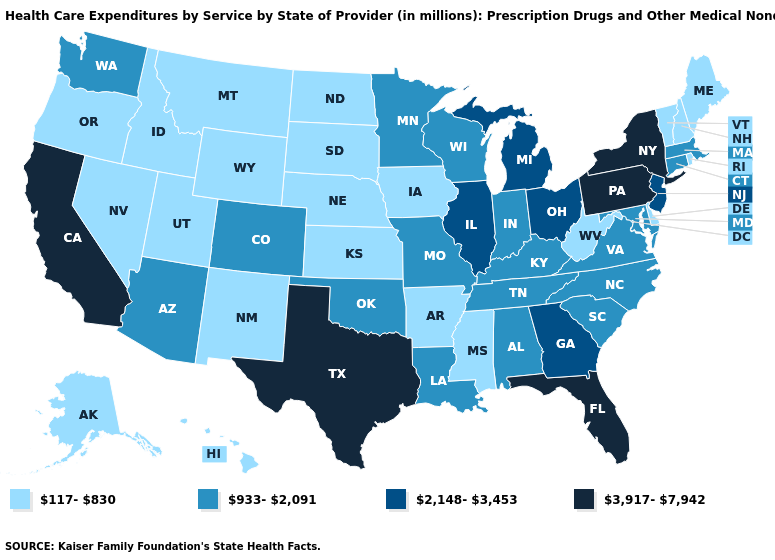Among the states that border Louisiana , does Mississippi have the lowest value?
Be succinct. Yes. What is the value of Idaho?
Keep it brief. 117-830. What is the value of Georgia?
Answer briefly. 2,148-3,453. Name the states that have a value in the range 117-830?
Give a very brief answer. Alaska, Arkansas, Delaware, Hawaii, Idaho, Iowa, Kansas, Maine, Mississippi, Montana, Nebraska, Nevada, New Hampshire, New Mexico, North Dakota, Oregon, Rhode Island, South Dakota, Utah, Vermont, West Virginia, Wyoming. What is the value of Colorado?
Be succinct. 933-2,091. Is the legend a continuous bar?
Give a very brief answer. No. Is the legend a continuous bar?
Give a very brief answer. No. What is the value of Nevada?
Answer briefly. 117-830. What is the value of New Hampshire?
Concise answer only. 117-830. Does Arkansas have the same value as Hawaii?
Be succinct. Yes. Which states hav the highest value in the MidWest?
Keep it brief. Illinois, Michigan, Ohio. Name the states that have a value in the range 2,148-3,453?
Short answer required. Georgia, Illinois, Michigan, New Jersey, Ohio. Name the states that have a value in the range 117-830?
Quick response, please. Alaska, Arkansas, Delaware, Hawaii, Idaho, Iowa, Kansas, Maine, Mississippi, Montana, Nebraska, Nevada, New Hampshire, New Mexico, North Dakota, Oregon, Rhode Island, South Dakota, Utah, Vermont, West Virginia, Wyoming. What is the value of Texas?
Quick response, please. 3,917-7,942. Does Texas have the highest value in the South?
Write a very short answer. Yes. 